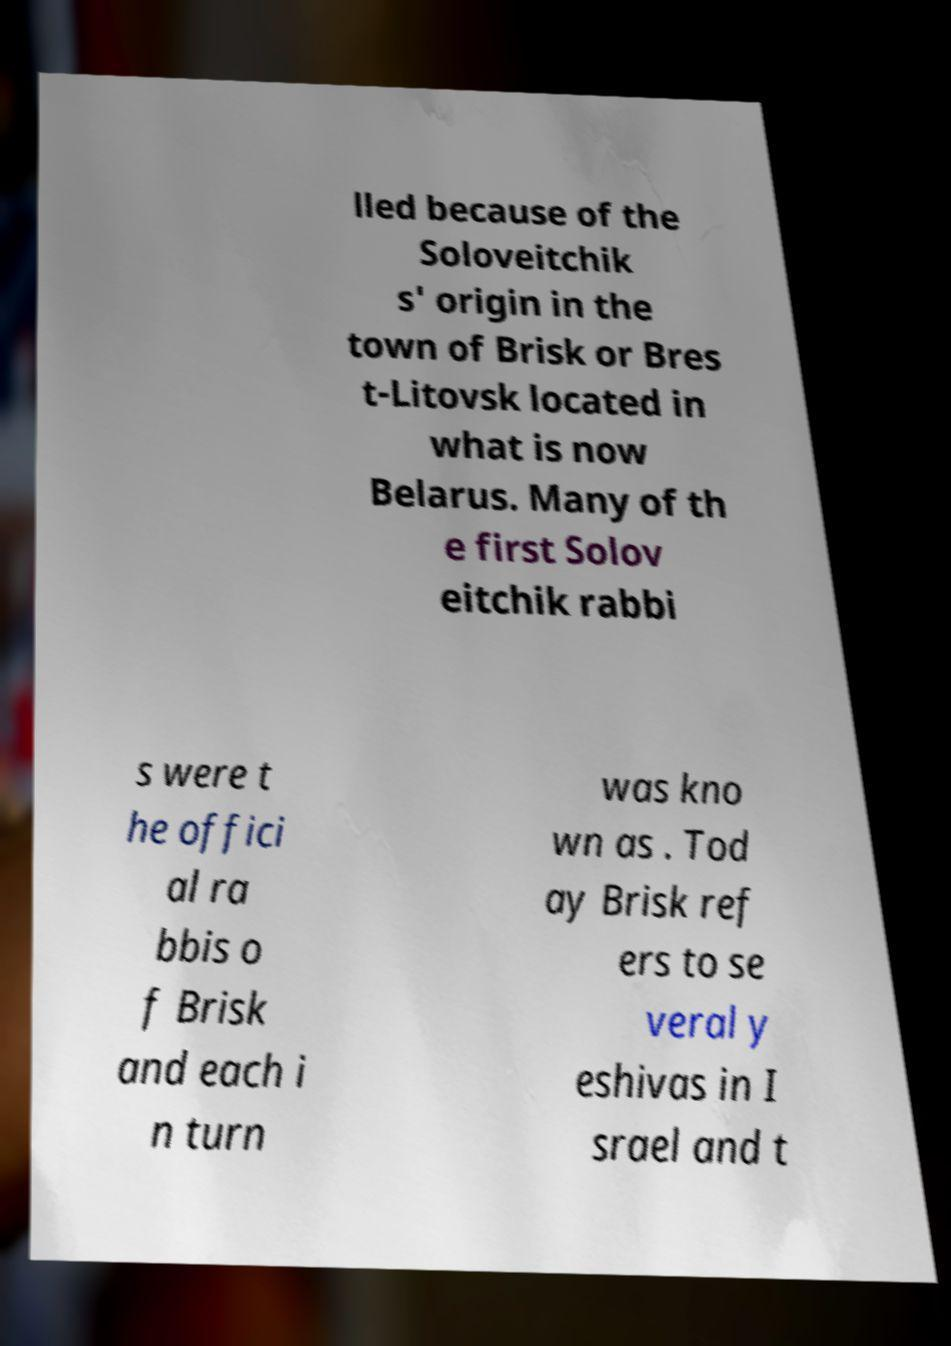Please read and relay the text visible in this image. What does it say? lled because of the Soloveitchik s' origin in the town of Brisk or Bres t-Litovsk located in what is now Belarus. Many of th e first Solov eitchik rabbi s were t he offici al ra bbis o f Brisk and each i n turn was kno wn as . Tod ay Brisk ref ers to se veral y eshivas in I srael and t 